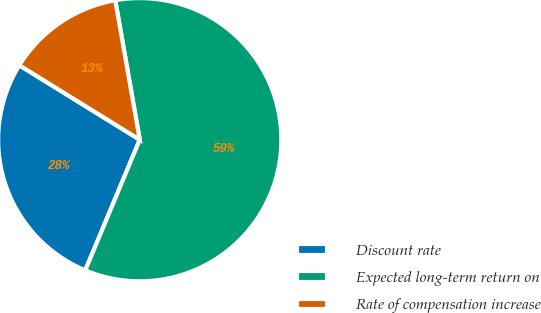Convert chart. <chart><loc_0><loc_0><loc_500><loc_500><pie_chart><fcel>Discount rate<fcel>Expected long-term return on<fcel>Rate of compensation increase<nl><fcel>27.52%<fcel>59.06%<fcel>13.42%<nl></chart> 